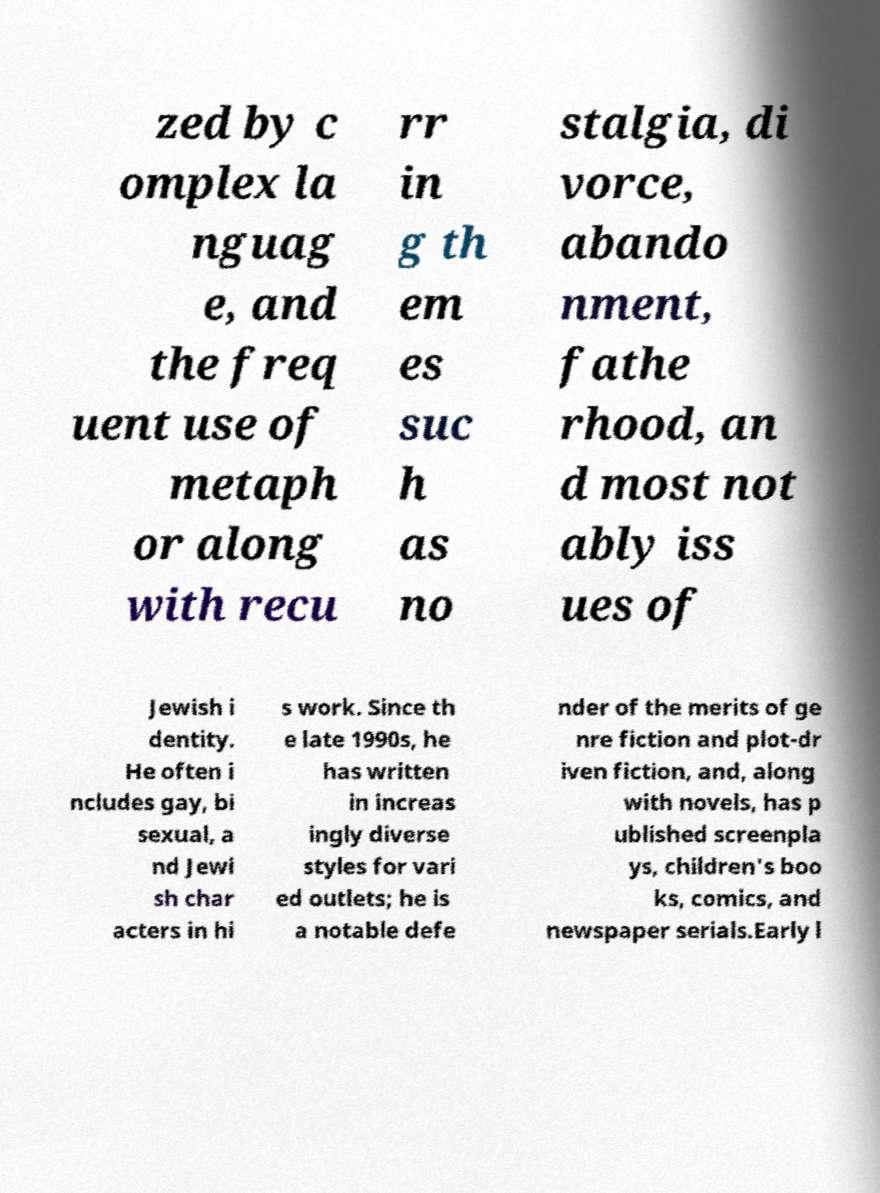I need the written content from this picture converted into text. Can you do that? zed by c omplex la nguag e, and the freq uent use of metaph or along with recu rr in g th em es suc h as no stalgia, di vorce, abando nment, fathe rhood, an d most not ably iss ues of Jewish i dentity. He often i ncludes gay, bi sexual, a nd Jewi sh char acters in hi s work. Since th e late 1990s, he has written in increas ingly diverse styles for vari ed outlets; he is a notable defe nder of the merits of ge nre fiction and plot-dr iven fiction, and, along with novels, has p ublished screenpla ys, children's boo ks, comics, and newspaper serials.Early l 